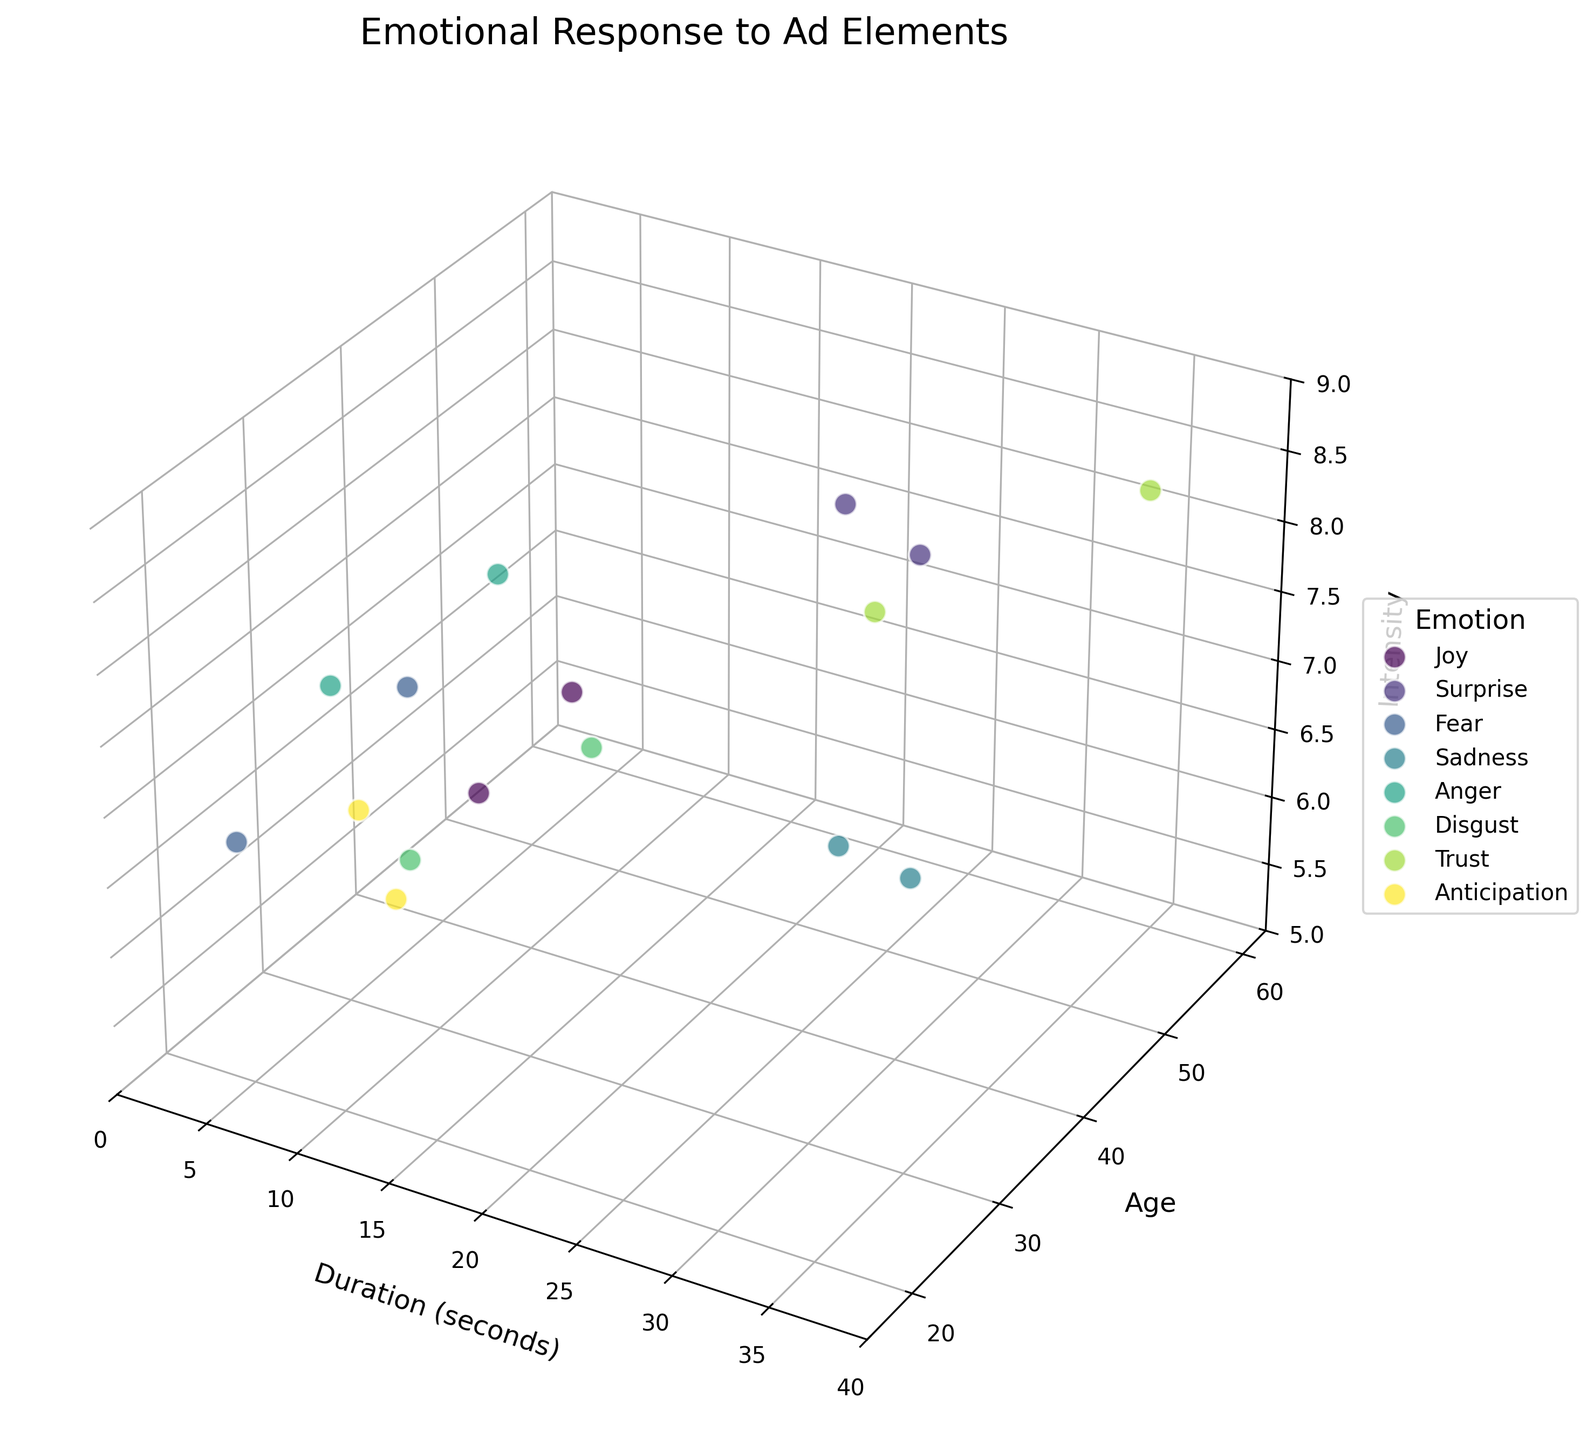What is the title of the figure? The title can be found at the top of the figure in larger, bolder text.
Answer: Emotional Response to Ad Elements Which emotion has the highest intensity? Look at the z-axis (Intensity) and the data points with the highest values.
Answer: Surprise What is the range of exposure duration displayed in the figure? Look at the x-axis (Duration) to see the minimum and maximum values it spans from.
Answer: 0 to 35 seconds What is the average Intensity for the Trust emotion? Locate the data points representing Trust (according to color/legend), then average the z-values (Intensity) of those points. (7.6 + 8.3) / 2 = 7.95
Answer: 7.95 What is the difference in Intensity between the Joy and Sadness emotions at their highest points? Find the highest Intensity values for both Joy and Sadness from the z-axis, then subtract the smaller from the larger. 7.8 - 5.9 = 1.9
Answer: 1.9 How many data points are associated with the Joy emotion? Identify and count the data points corresponding to Joy according to the color/legend.
Answer: 2 Which emotion shows the most variation in Age demographic? Compare the range of ages across the data points for each emotion.
Answer: Trust Is there an emotion that consistently appears within a specific duration range? Look at the x-axis values for each emotion to determine if any emotion's data points cluster within a specific range.
Answer: No Which emotion represents the oldest viewer demographic? Identify the emotion associated with the highest value on the y-axis (Age).
Answer: Trust Among the emotions with multiple data points, which has the most consistent Intensity? For emotions with more than one data point, compare the variances in the z-axis values (Intensity) to find the smallest variability.
Answer: Disgust 